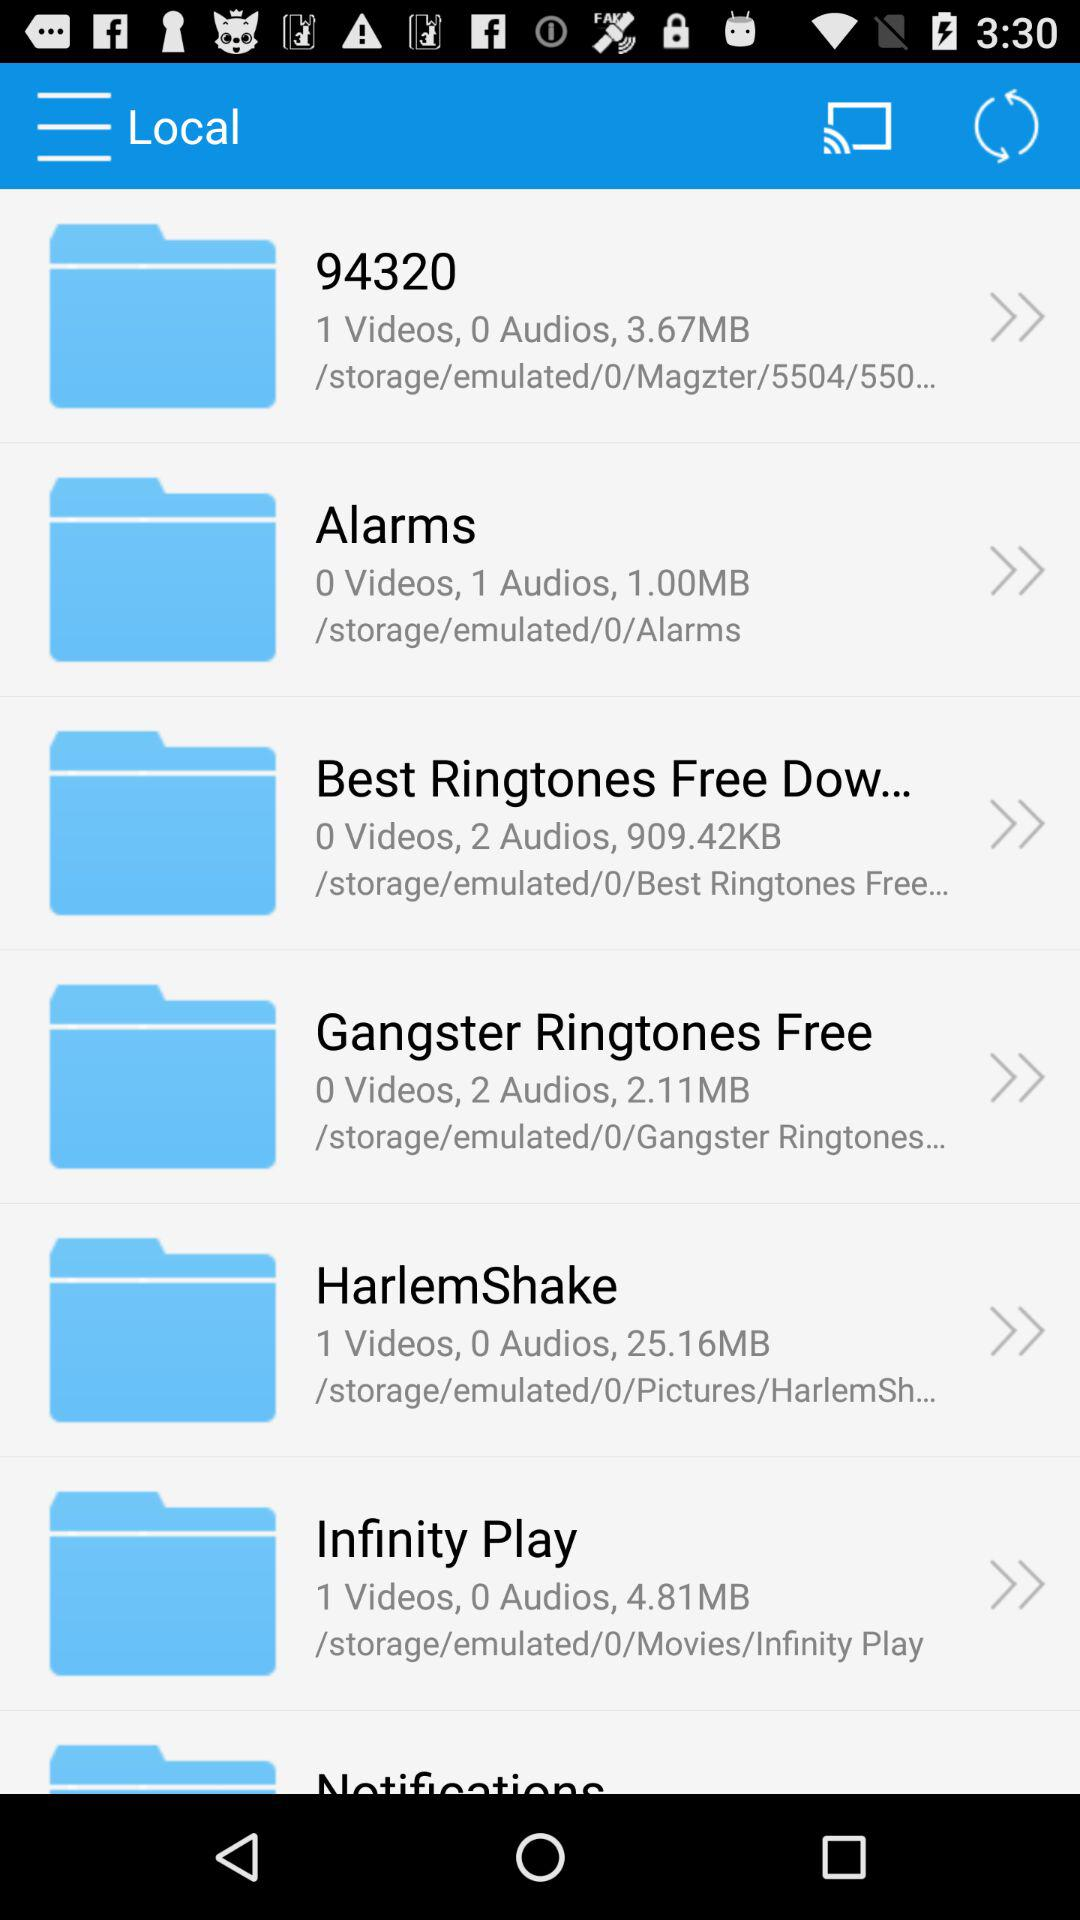How many videos are there in the "Infinity Play" folder? There is 1 video in the "Infinity Play" folder. 